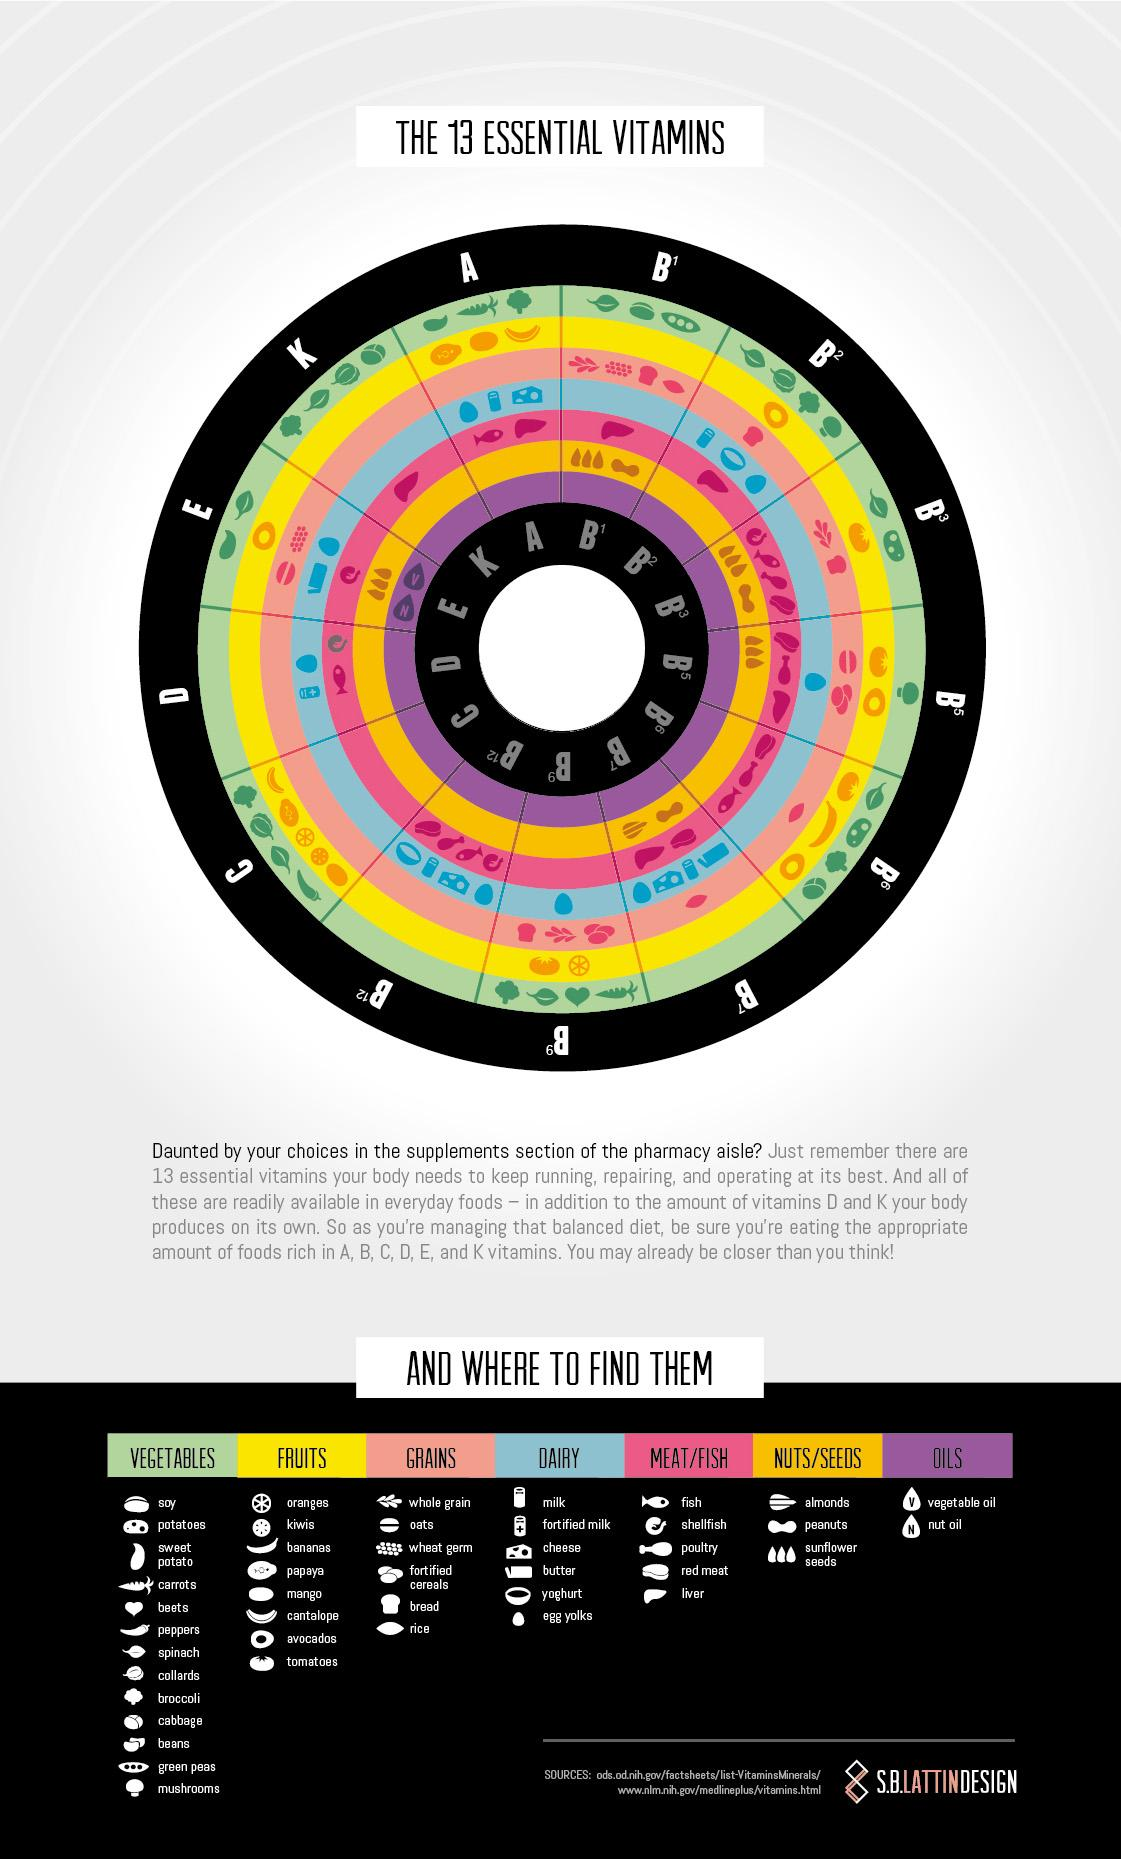Identify some key points in this picture. The vitamin you will receive from four of the five fish/meat items listed here is B3. Mushrooms are a source of vitamin B5. Egg yolks are a source of vitamin B9. The vitamin that is obtained from cantaloupe, papaya, kiwis, orange, and mango is vitamin C. Avocados are a fruit that contain vitamin B2. 